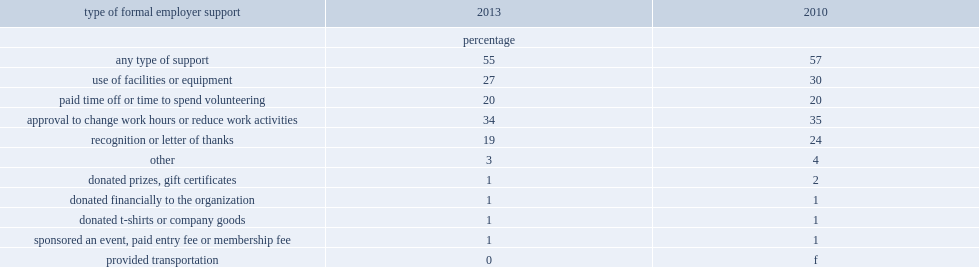What is the percentage of volunteers receiving some form of formal support from their employer in 2013? 55.0. What is the percentage of employed volunteers indicating that their employer approves either a change in work hours or a reduction in work activities in 2013? 34.0. What is the percentage of the ability to take time off, whether paid or unpaid, to volunteer reported by volunteers in 2013? 20.0. What is the percentage of volunteers saying that their employer allowed the use of facilities or equipment in 2013? 27.0. Which type is the second most common form of employer support in 2013? Use of facilities or equipment. In which year is the prevalence of formal recognition or letter of thanks less , 2010 or 2013? 2013.0. What is the prevalence of formal recognition or letter of thanks in 2010? 24.0. What is the prevalence of formal recognition or letter of thanks in 2013? 19.0. 